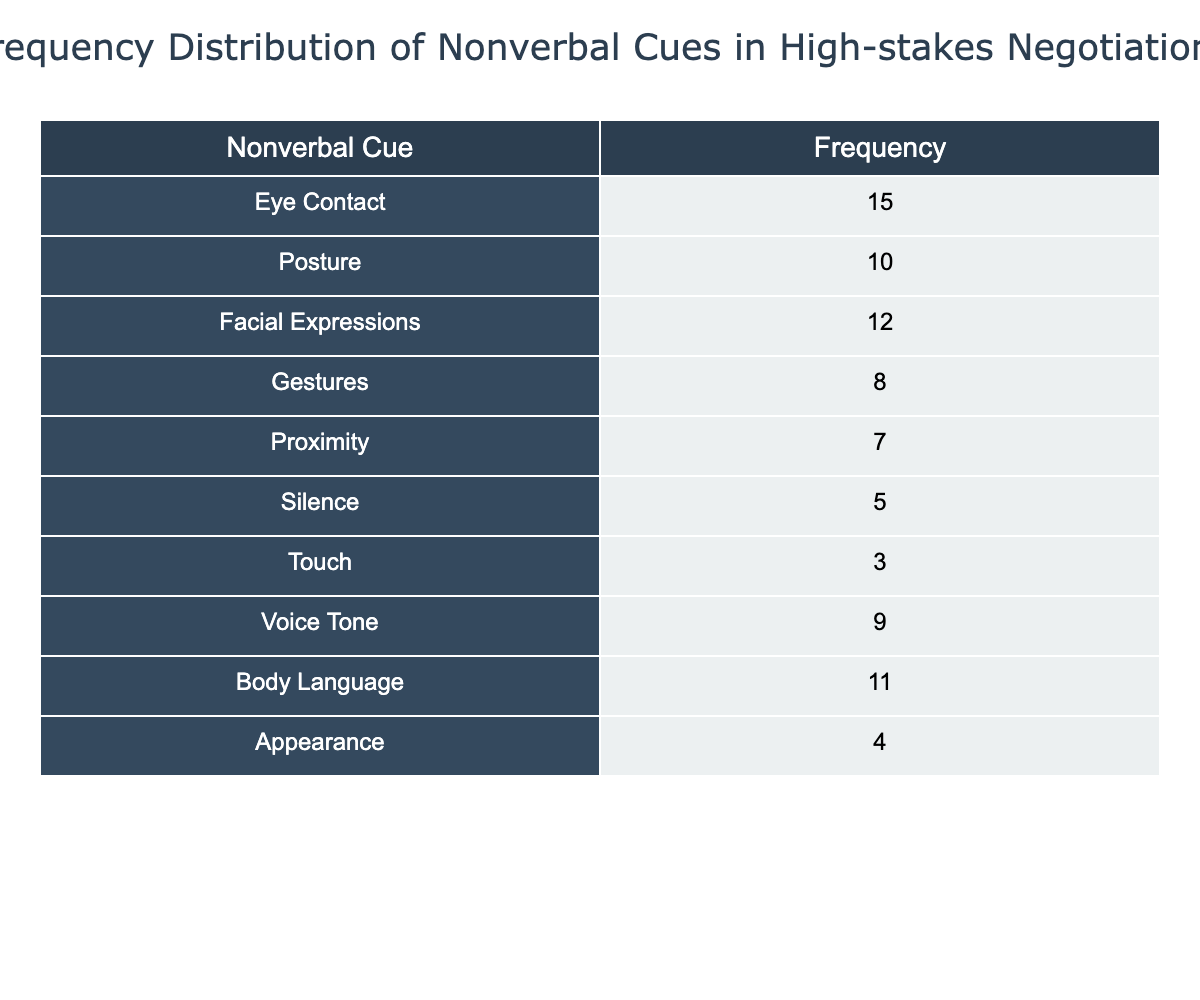What is the frequency of Eye Contact in high-stakes negotiations? From the table, we can directly find the value next to "Eye Contact," which shows a frequency of 15.
Answer: 15 Which nonverbal cue has the lowest frequency? By examining the table, we see that "Touch" has the lowest frequency at 3.
Answer: Touch What is the total frequency of all the nonverbal cues combined? To find the total frequency, add the frequencies: 15 (Eye Contact) + 10 (Posture) + 12 (Facial Expressions) + 8 (Gestures) + 7 (Proximity) + 5 (Silence) + 3 (Touch) + 9 (Voice Tone) + 11 (Body Language) + 4 (Appearance) = 70.
Answer: 70 Is the frequency of Gestures greater than that of Silence? By looking at the table, Gestures have a frequency of 8 and Silence has a frequency of 5. Since 8 is greater than 5, the answer is yes.
Answer: Yes What is the average frequency of the nonverbal cues in the table? To calculate the average, sum the total frequency (which is 70) and divide by the number of nonverbal cues (10). Therefore, 70/10 = 7.
Answer: 7 If we consider only the frequencies of Body Language, Voice Tone, and Posture, what is their combined frequency? The frequencies for Body Language, Voice Tone, and Posture are 11, 9, and 10, respectively. Adding these together gives us 11 + 9 + 10 = 30.
Answer: 30 Is it true that more nonverbal cues have a frequency of 10 or higher than those below 10? The table indicates that there are six nonverbal cues with frequencies of 10 or higher (Eye Contact, Posture, Facial Expressions, Body Language, Voice Tone) and four below 10 (Gestures, Proximity, Silence, Touch). This shows that there are indeed more nonverbal cues with frequencies of 10 or higher.
Answer: Yes What is the frequency difference between Facial Expressions and Voice Tone? From the table, Facial Expressions has a frequency of 12 and Voice Tone has a frequency of 9. The difference is calculated as 12 - 9 = 3.
Answer: 3 How many nonverbal cues have a frequency of less than 5? From the table, we can see that only "Touch" and "Silence" have frequencies less than 5, which totals to 2 nonverbal cues.
Answer: 2 